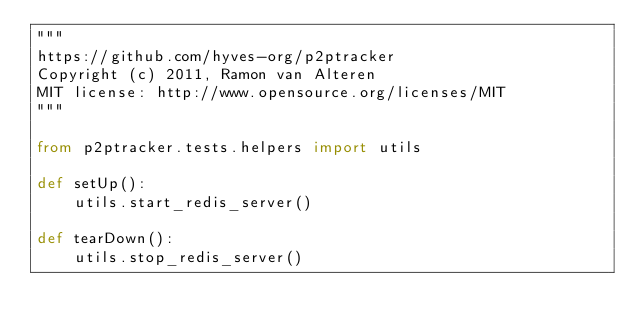<code> <loc_0><loc_0><loc_500><loc_500><_Python_>"""
https://github.com/hyves-org/p2ptracker
Copyright (c) 2011, Ramon van Alteren
MIT license: http://www.opensource.org/licenses/MIT
"""

from p2ptracker.tests.helpers import utils

def setUp():
    utils.start_redis_server()

def tearDown():
    utils.stop_redis_server()

</code> 